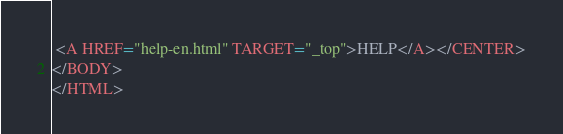Convert code to text. <code><loc_0><loc_0><loc_500><loc_500><_HTML_> <A HREF="help-en.html" TARGET="_top">HELP</A></CENTER>
</BODY>
</HTML>
</code> 